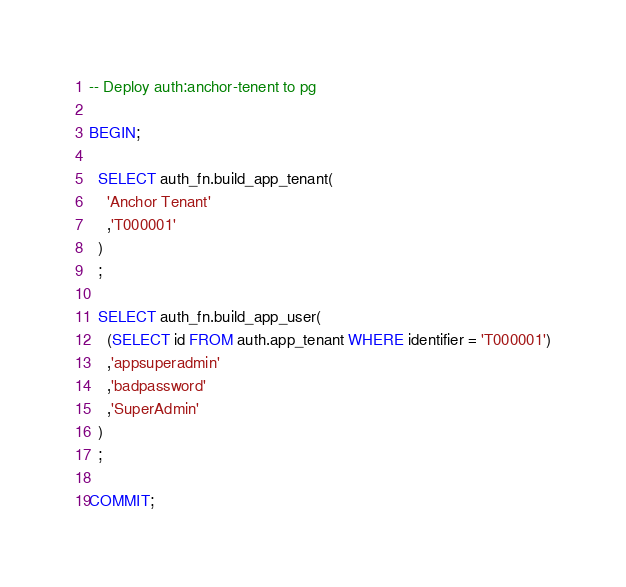<code> <loc_0><loc_0><loc_500><loc_500><_SQL_>-- Deploy auth:anchor-tenent to pg

BEGIN;

  SELECT auth_fn.build_app_tenant(
    'Anchor Tenant'
    ,'T000001'
  )
  ;

  SELECT auth_fn.build_app_user(
    (SELECT id FROM auth.app_tenant WHERE identifier = 'T000001')
    ,'appsuperadmin'
    ,'badpassword'
    ,'SuperAdmin'
  )
  ;

COMMIT;
</code> 